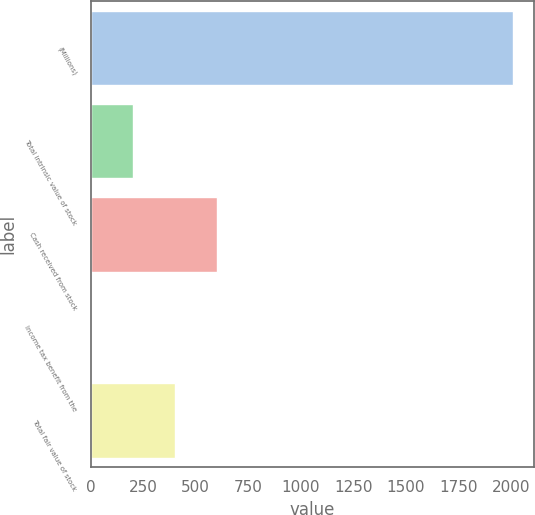Convert chart to OTSL. <chart><loc_0><loc_0><loc_500><loc_500><bar_chart><fcel>(Millions)<fcel>Total intrinsic value of stock<fcel>Cash received from stock<fcel>Income tax benefit from the<fcel>Total fair value of stock<nl><fcel>2009<fcel>201.8<fcel>603.4<fcel>1<fcel>402.6<nl></chart> 